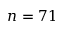<formula> <loc_0><loc_0><loc_500><loc_500>n = 7 1</formula> 